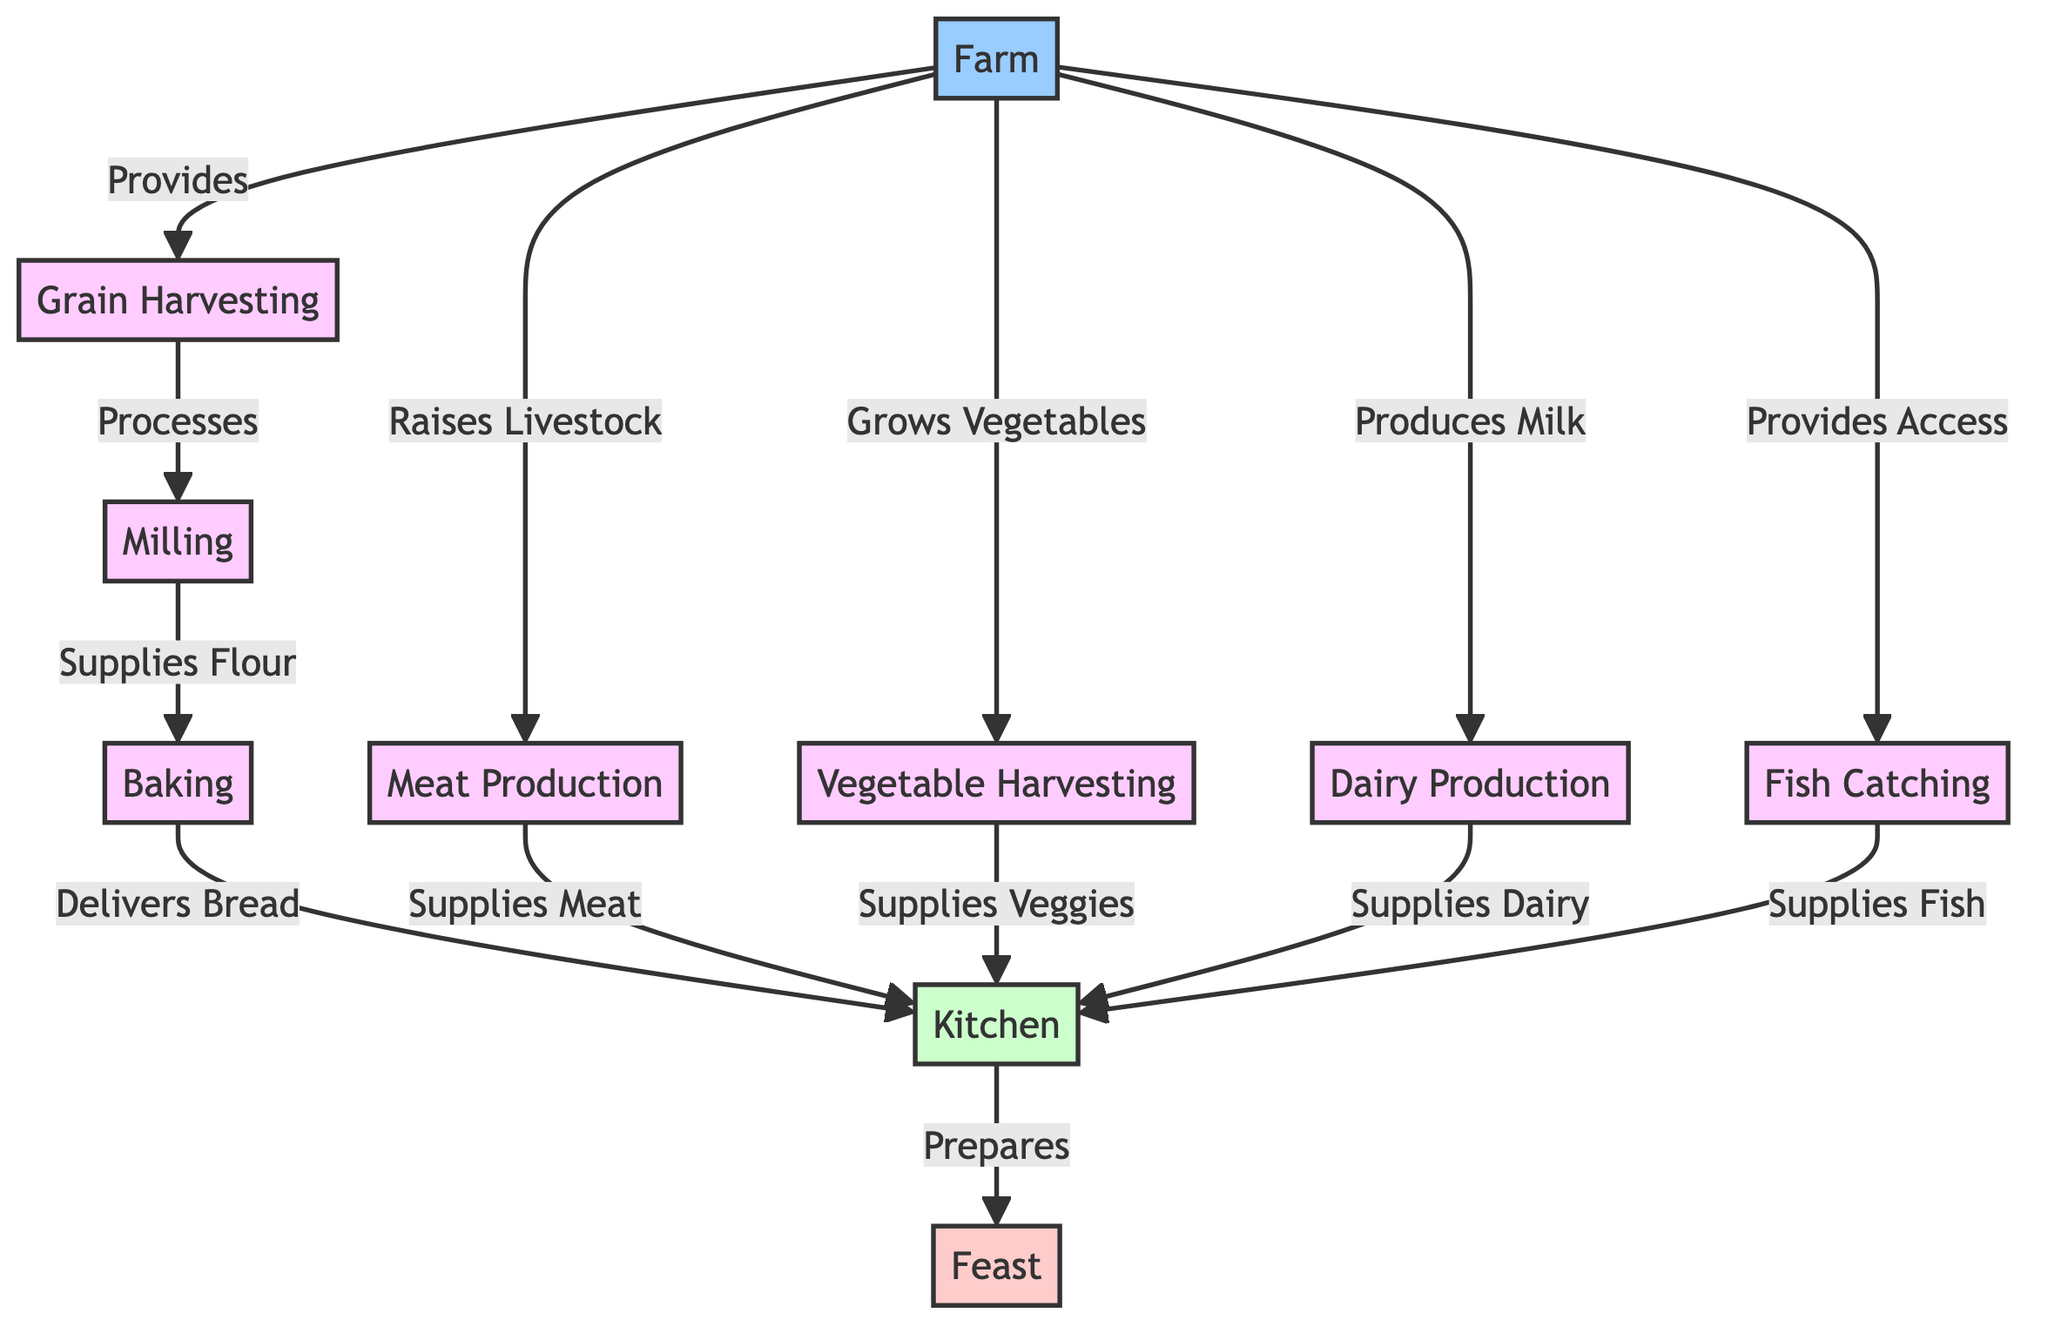What is the first step in the medieval agrarian food chain? The first step in the diagram, represented by the node labeled "Farm," indicates that farming is the foundational activity for the food chain.
Answer: Farm How many main processes are there in the food chain? By counting the process nodes—Grain Harvesting, Milling, Baking, Meat Production, Vegetable Harvesting, Dairy Production, and Fish Catching—I find there are seven main processes.
Answer: 7 What does the farm provide for grain production? The diagram shows that the farm specifically provides the grain that is harvested, denoted by the arrow that connects "Farm" to "Grain Harvesting."
Answer: Grain What does milling supply for baking? The arrow from "Milling" to "Baking" indicates that milling supplies flour, which is necessary for the baking process.
Answer: Flour Which processes supply food to the kitchen? The kitchen receives supplies from multiple processes: grain (as bread), meat, vegetables, dairy, and fish, each of which contributes to the kitchen activities.
Answer: Meat, Vegetables, Dairy, Fish What is the final outcome of the food chain? The final node labeled "Feast" signifies the culmination of all processes and supplies that converge to result in a feast.
Answer: Feast What is the relationship between dairy production and the kitchen? The connection shows that dairy production supplies the kitchen with dairy products for the meals prepared there; this relationship is indicated by the arrow from "Dairy Production" to "Kitchen."
Answer: Supplies Dairy How does fish catch relate to the overall food chain? The diagram indicates that fish catching provides fish to the kitchen, highlighting its role as a source of protein in the diet and thus representing a critical component of the food chain.
Answer: Supplies Fish 